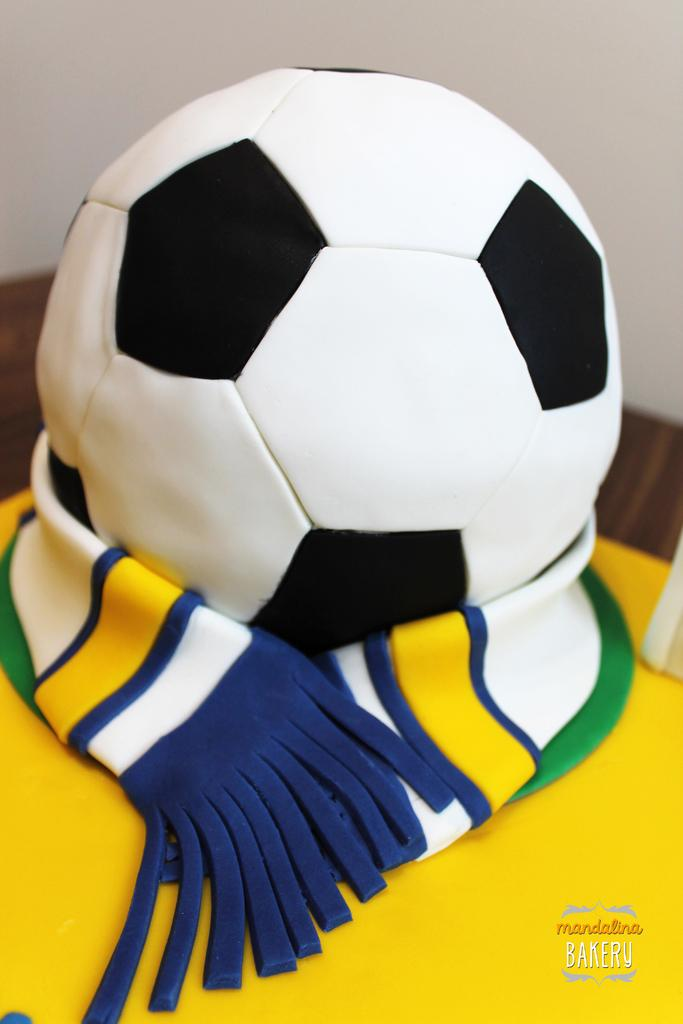What is the main subject in the foreground of the image? There is a cake in the foreground of the image. What color is the cloth at the bottom of the image? The cloth at the bottom of the image is yellow. What object is located in the middle of the image? There is a ball in the middle of the image. What can be seen in the background of the image? There is a wall in the background of the image. What type of knee injury can be seen in the image? There is no knee injury present in the image. What event is causing the thrill in the image? There is no event or thrill depicted in the image; it features a cake, a yellow cloth, a ball, and a wall. 